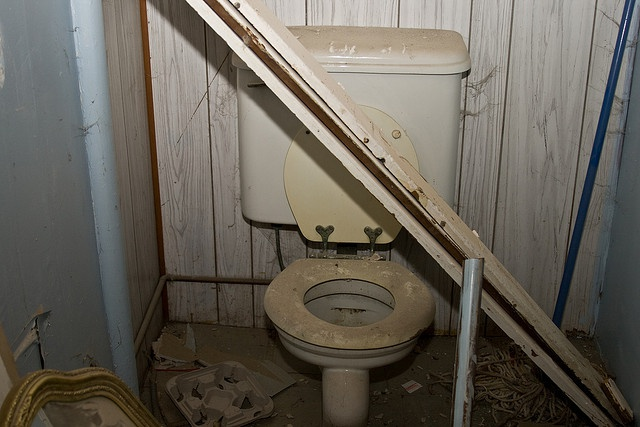Describe the objects in this image and their specific colors. I can see a toilet in gray and darkgray tones in this image. 